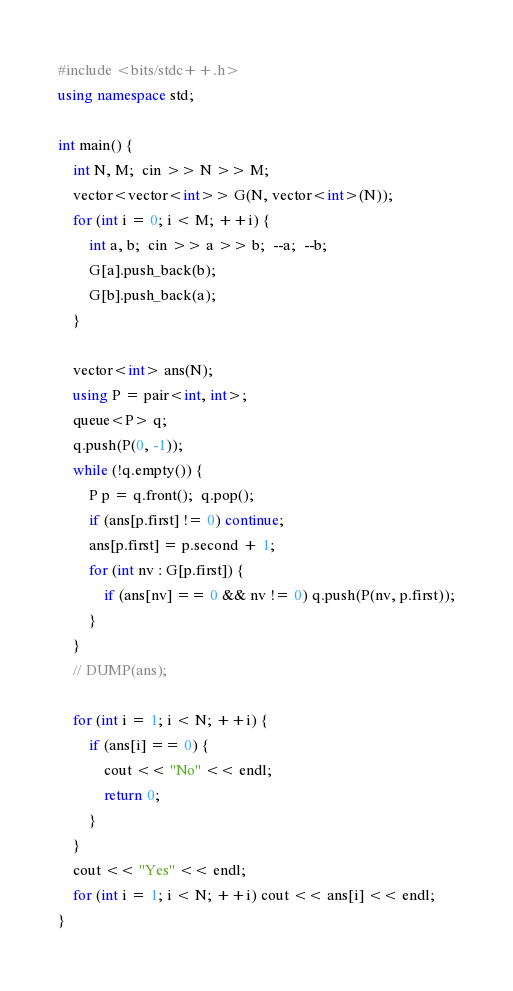<code> <loc_0><loc_0><loc_500><loc_500><_C++_>#include <bits/stdc++.h>
using namespace std;

int main() {
    int N, M;  cin >> N >> M;
    vector<vector<int>> G(N, vector<int>(N));
    for (int i = 0; i < M; ++i) {
        int a, b;  cin >> a >> b;  --a;  --b;
        G[a].push_back(b);
        G[b].push_back(a);
    }

    vector<int> ans(N);
    using P = pair<int, int>;
    queue<P> q;
    q.push(P(0, -1));
    while (!q.empty()) {
        P p = q.front();  q.pop();
        if (ans[p.first] != 0) continue;
        ans[p.first] = p.second + 1;
        for (int nv : G[p.first]) {
            if (ans[nv] == 0 && nv != 0) q.push(P(nv, p.first));
        }
    }
    // DUMP(ans);

    for (int i = 1; i < N; ++i) {
        if (ans[i] == 0) {
            cout << "No" << endl;
            return 0;
        }
    }
    cout << "Yes" << endl;
    for (int i = 1; i < N; ++i) cout << ans[i] << endl;
}
</code> 